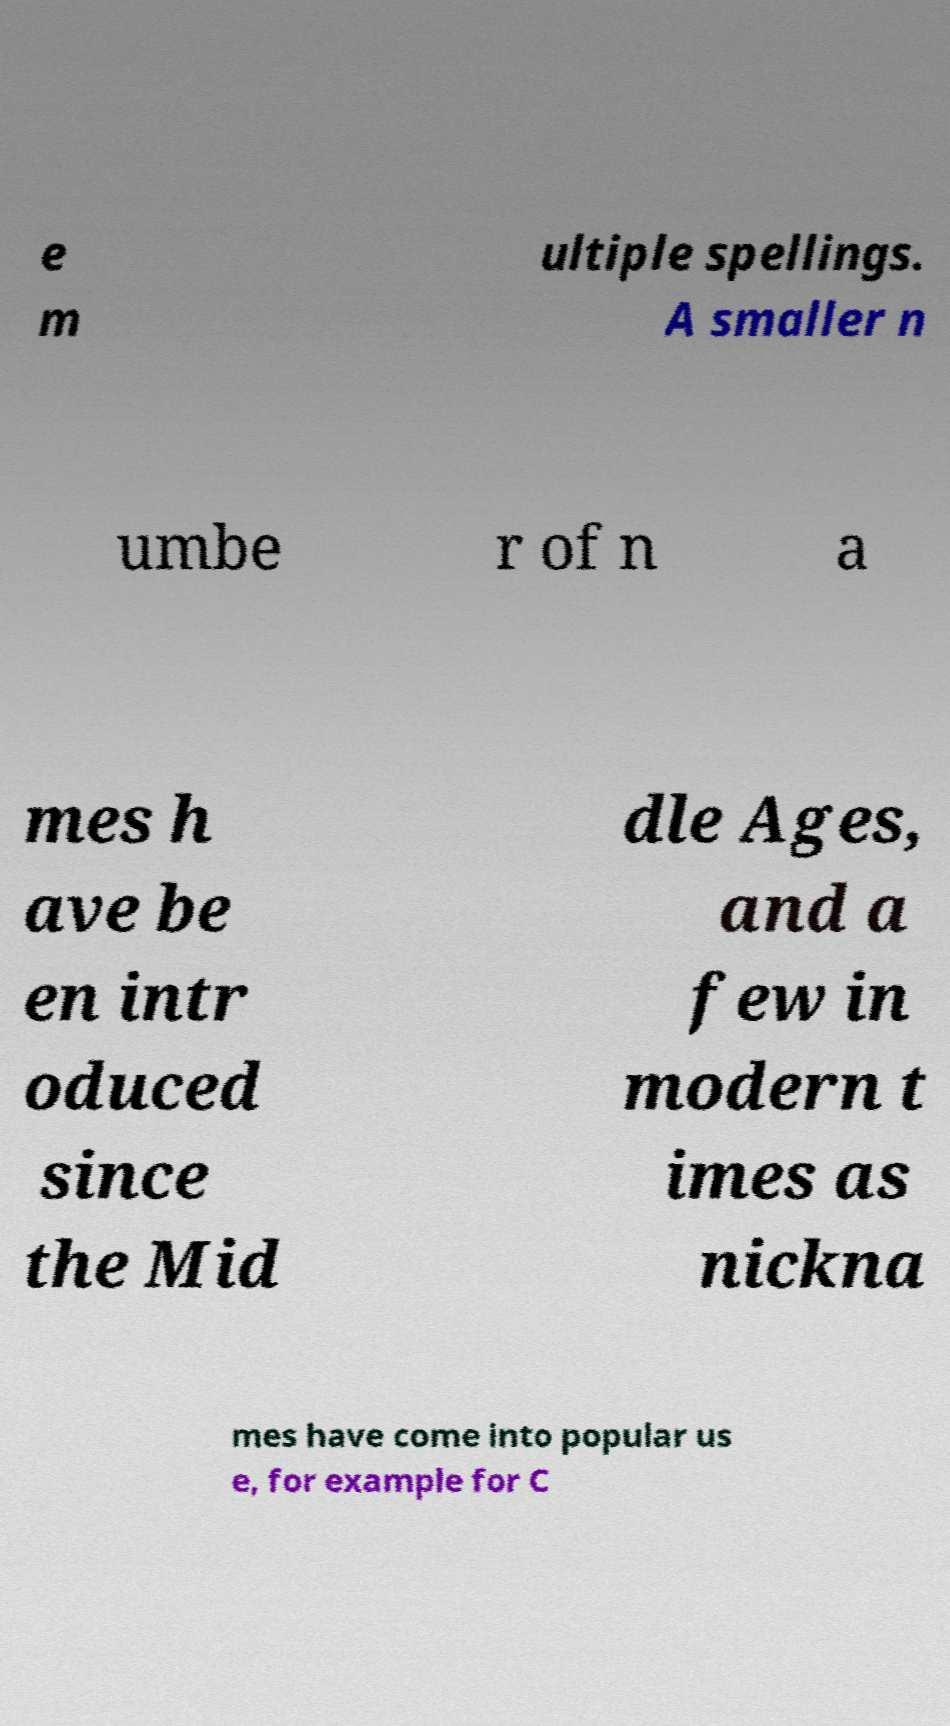There's text embedded in this image that I need extracted. Can you transcribe it verbatim? e m ultiple spellings. A smaller n umbe r of n a mes h ave be en intr oduced since the Mid dle Ages, and a few in modern t imes as nickna mes have come into popular us e, for example for C 